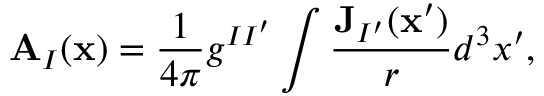Convert formula to latex. <formula><loc_0><loc_0><loc_500><loc_500>A _ { I } ( x ) = \frac { 1 } { 4 \pi } g ^ { I I ^ { \prime } } \int \frac { J _ { I ^ { \prime } } ( x ^ { \prime } ) } { r } d ^ { 3 } x ^ { \prime } ,</formula> 